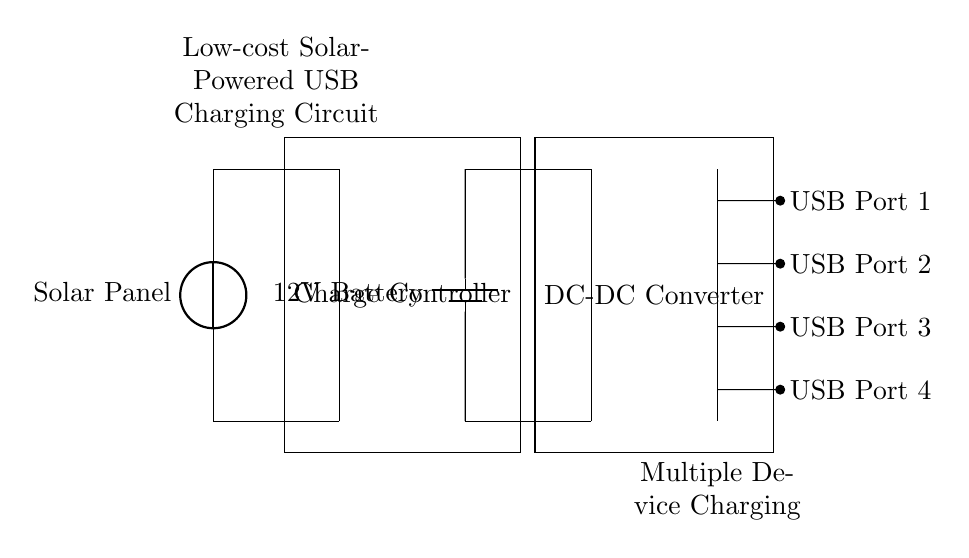What is the main component of this circuit? The main component is the solar panel, which is used to convert solar energy into electrical energy that powers the circuit.
Answer: solar panel How many USB ports are in this circuit? There are four USB ports, which allow multiple devices to be charged simultaneously.
Answer: four What type of battery is used in this circuit? The battery used in this circuit is a 12V battery, providing the necessary voltage for charging.
Answer: 12V battery What is the purpose of the charge controller? The charge controller regulates the voltage and current from the solar panel to ensure that the battery is charged safely and efficiently.
Answer: regulates voltage What is the output voltage from the DC-DC converter? The output voltage from the DC-DC converter is typically adjusted to match the voltage required for USB devices, which is usually 5V.
Answer: 5V What is the function of the DC-DC converter in this circuit? The function of the DC-DC converter is to step down the voltage from the battery to a suitable level for the USB output, making it compatible with USB devices.
Answer: step down voltage 